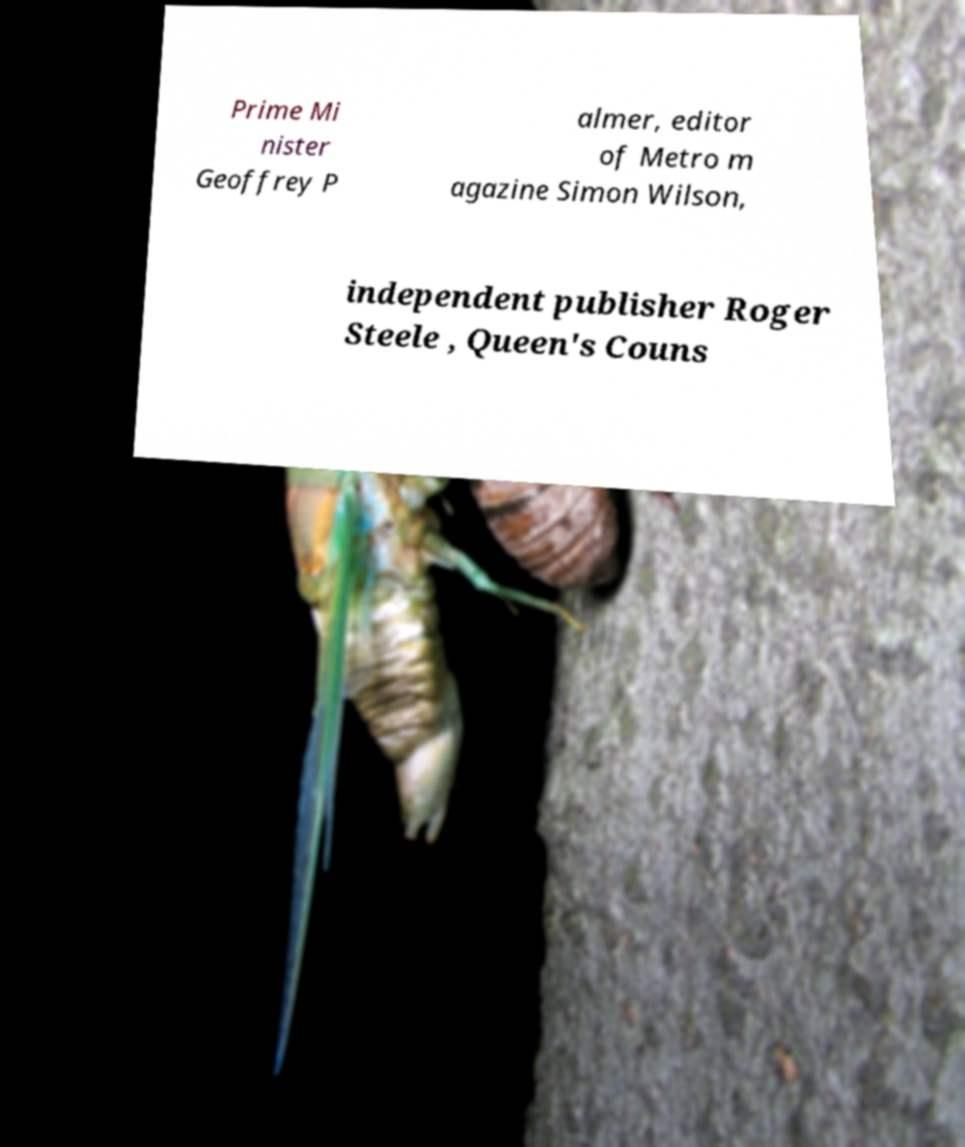Can you accurately transcribe the text from the provided image for me? Prime Mi nister Geoffrey P almer, editor of Metro m agazine Simon Wilson, independent publisher Roger Steele , Queen's Couns 